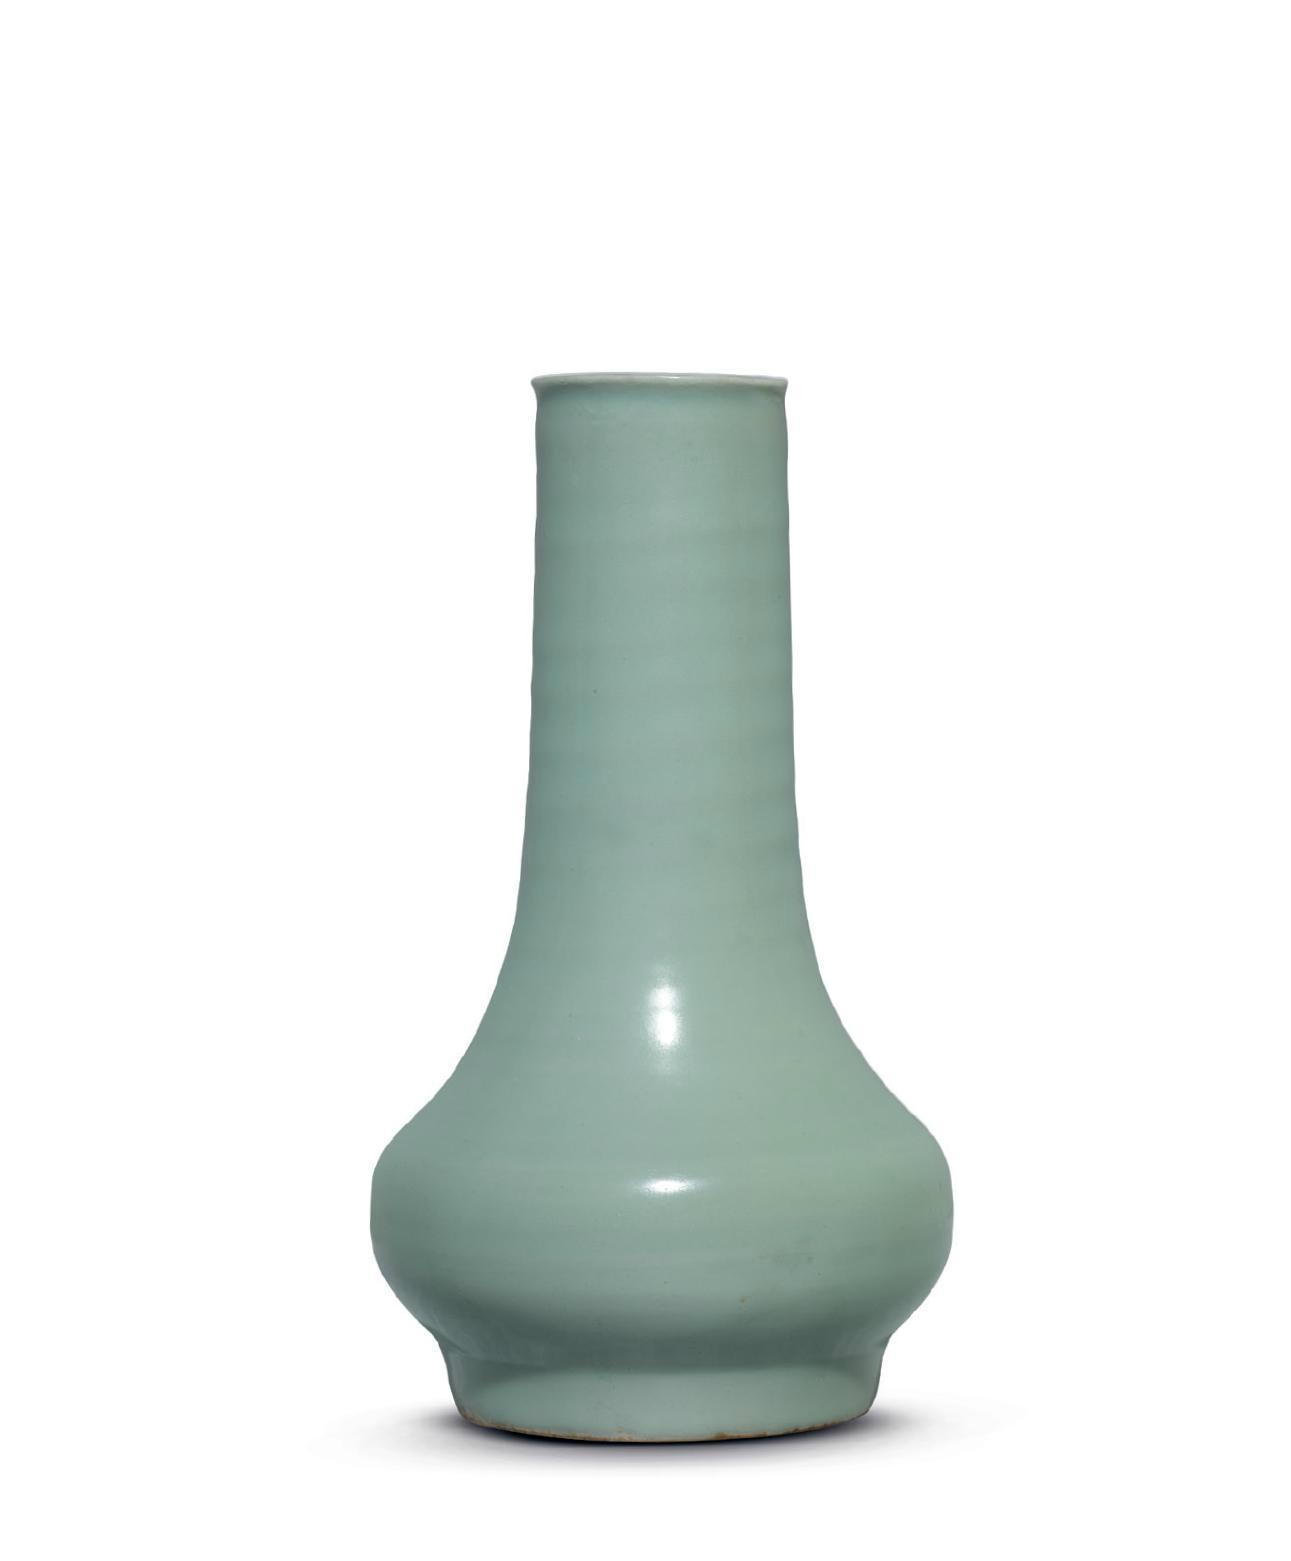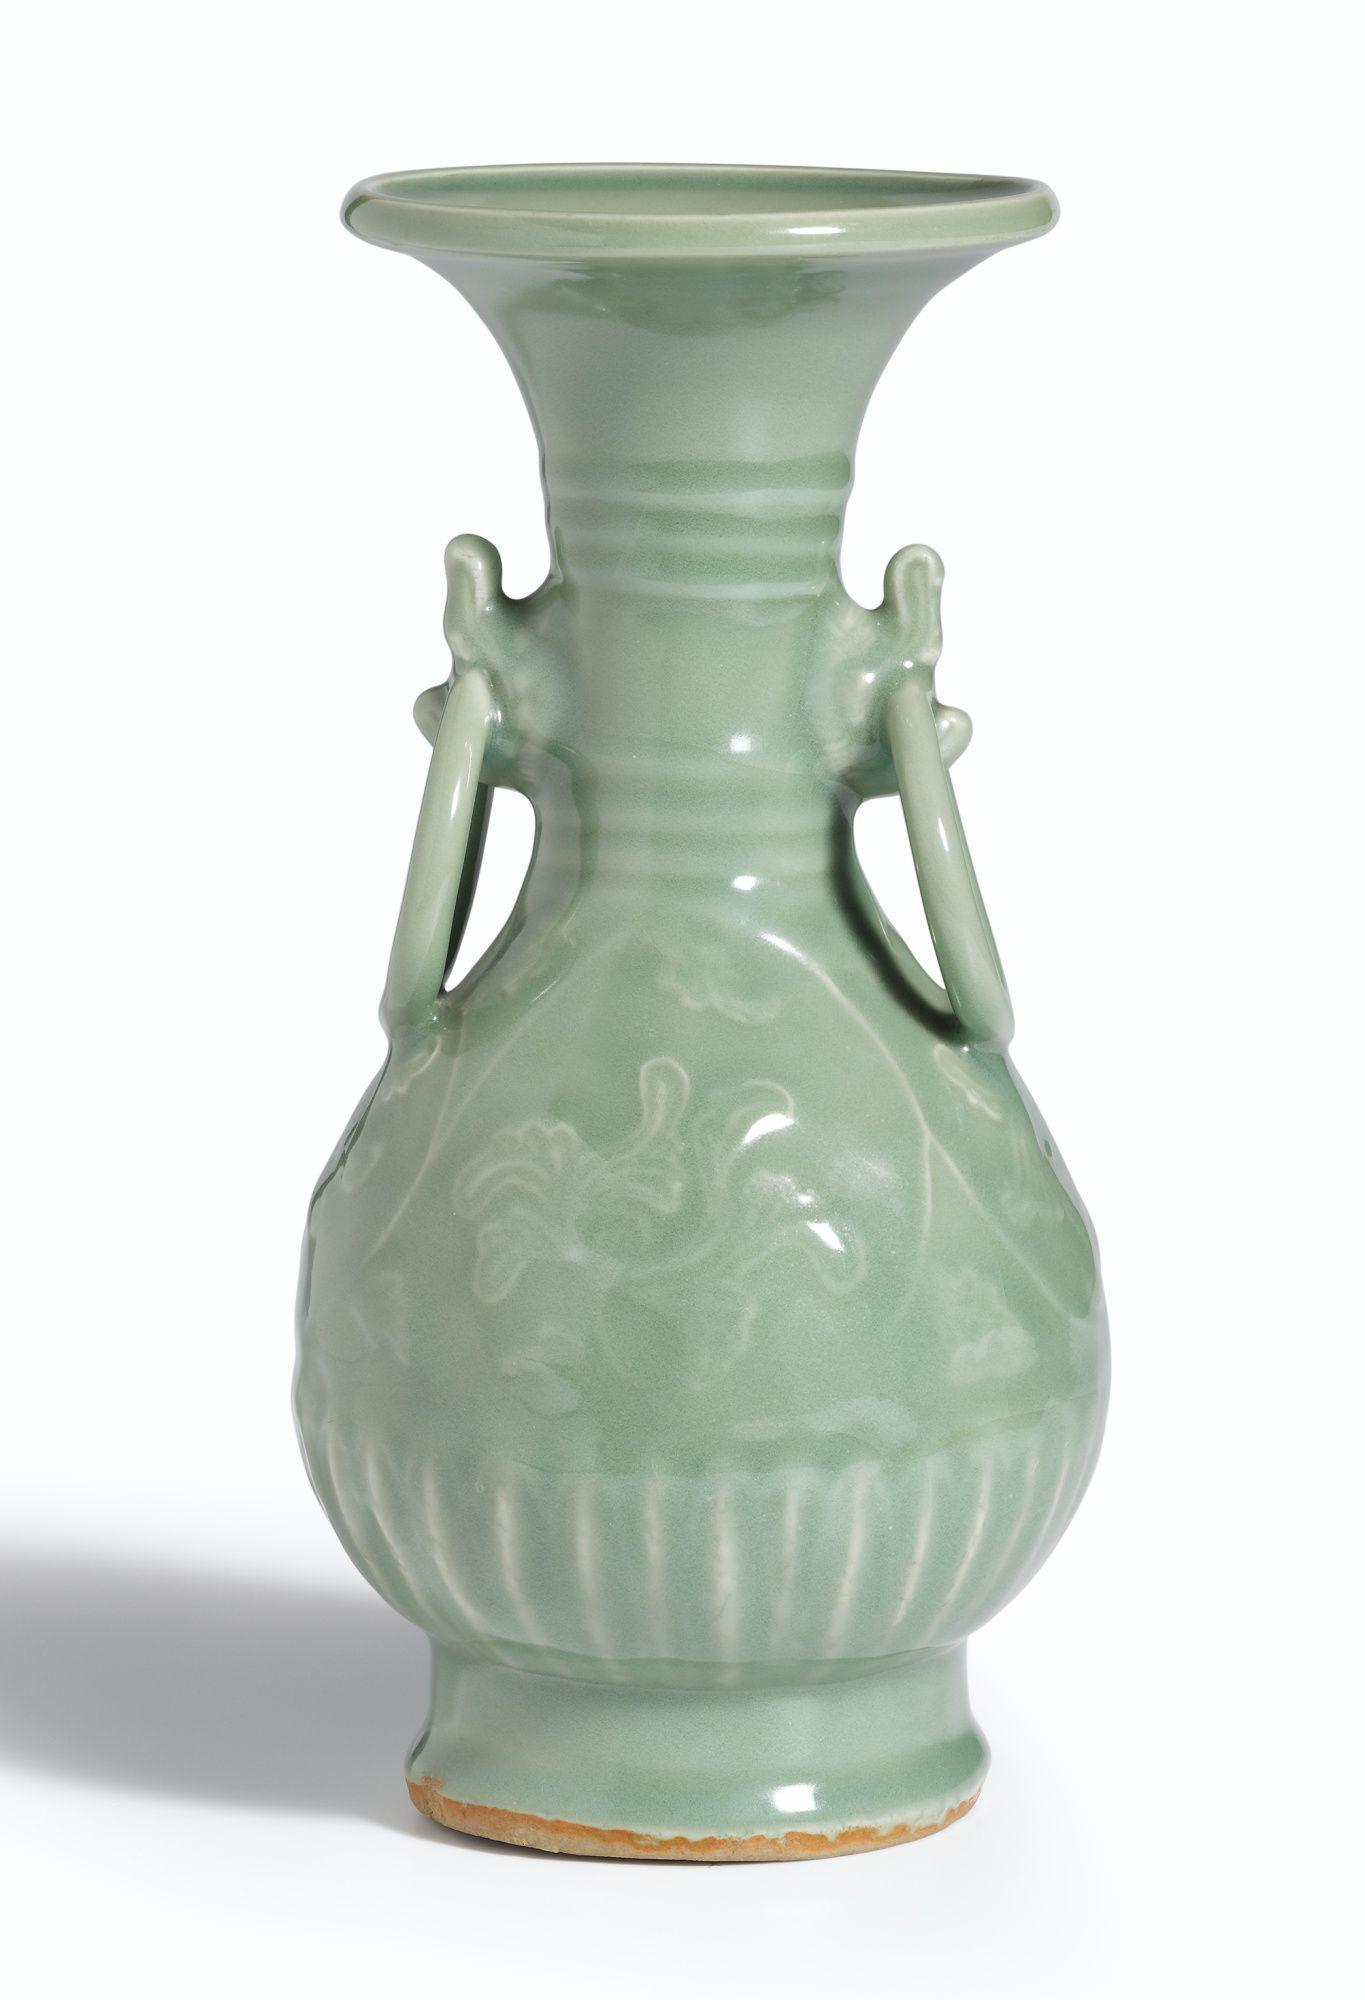The first image is the image on the left, the second image is the image on the right. Examine the images to the left and right. Is the description "One of the vases has slender handles on each side, a dimensional ribbed element, and a fluted top." accurate? Answer yes or no. Yes. 